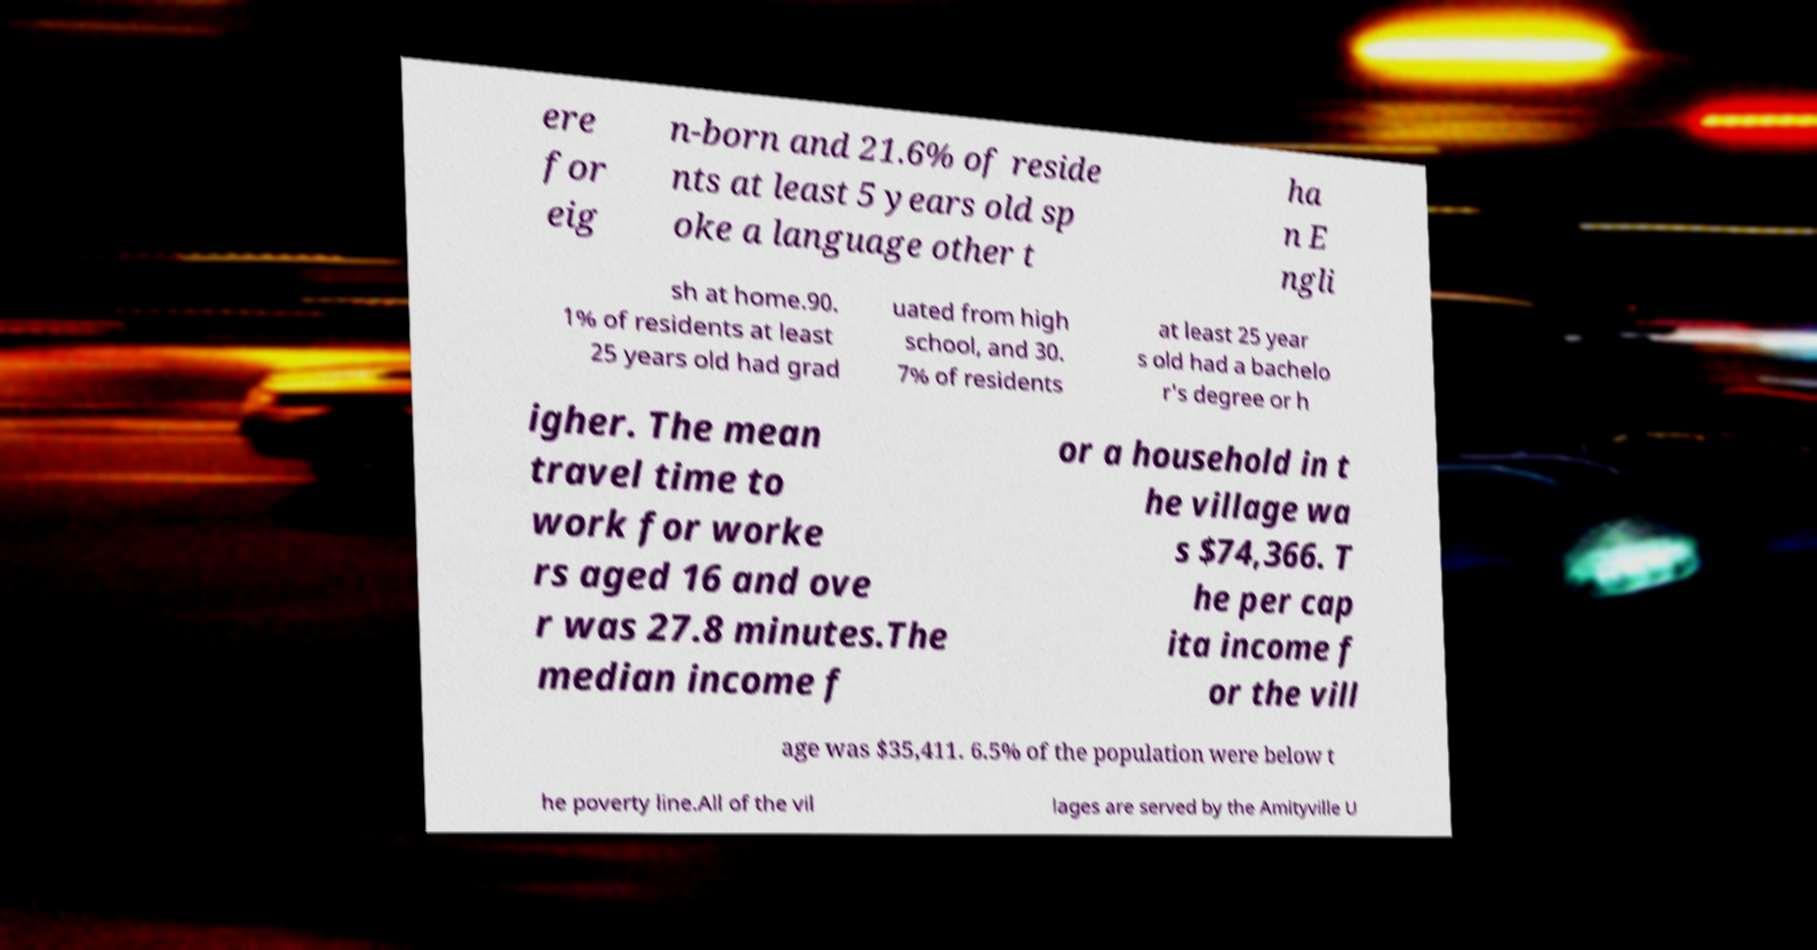Please read and relay the text visible in this image. What does it say? ere for eig n-born and 21.6% of reside nts at least 5 years old sp oke a language other t ha n E ngli sh at home.90. 1% of residents at least 25 years old had grad uated from high school, and 30. 7% of residents at least 25 year s old had a bachelo r's degree or h igher. The mean travel time to work for worke rs aged 16 and ove r was 27.8 minutes.The median income f or a household in t he village wa s $74,366. T he per cap ita income f or the vill age was $35,411. 6.5% of the population were below t he poverty line.All of the vil lages are served by the Amityville U 